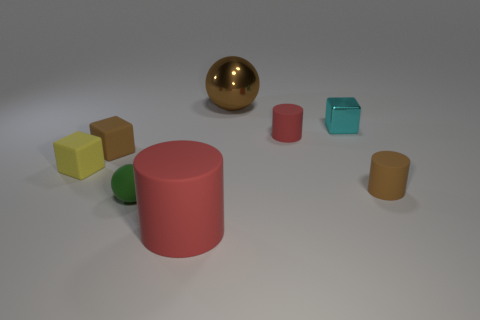Do the metallic block and the green object have the same size?
Your response must be concise. Yes. There is a metal thing that is left of the tiny red thing that is on the right side of the green thing; what color is it?
Your answer should be very brief. Brown. The rubber sphere is what color?
Keep it short and to the point. Green. Are there any small cylinders that have the same color as the large cylinder?
Provide a succinct answer. Yes. Do the small rubber thing that is to the right of the tiny cyan shiny thing and the big shiny ball have the same color?
Your answer should be very brief. Yes. How many things are matte cylinders that are on the left side of the tiny cyan metallic object or balls?
Give a very brief answer. 4. Are there any tiny objects left of the small green rubber object?
Offer a terse response. Yes. Are the brown object left of the big red rubber cylinder and the cyan block made of the same material?
Offer a very short reply. No. Is there a tiny rubber object left of the tiny brown thing that is right of the sphere that is to the left of the large brown ball?
Your answer should be compact. Yes. What number of cylinders are either small brown rubber objects or rubber objects?
Make the answer very short. 3. 